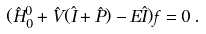Convert formula to latex. <formula><loc_0><loc_0><loc_500><loc_500>( \hat { H } ^ { 0 } _ { 0 } + \hat { V } ( \hat { I } + \hat { P } ) - E \hat { I } ) { f } = 0 \, .</formula> 